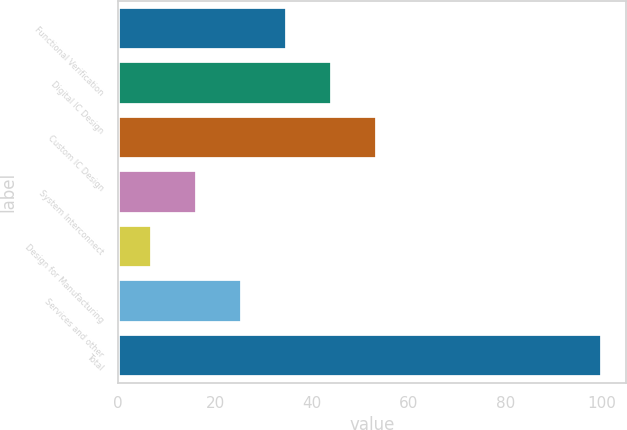<chart> <loc_0><loc_0><loc_500><loc_500><bar_chart><fcel>Functional Verification<fcel>Digital IC Design<fcel>Custom IC Design<fcel>System Interconnect<fcel>Design for Manufacturing<fcel>Services and other<fcel>Total<nl><fcel>34.9<fcel>44.2<fcel>53.5<fcel>16.3<fcel>7<fcel>25.6<fcel>100<nl></chart> 